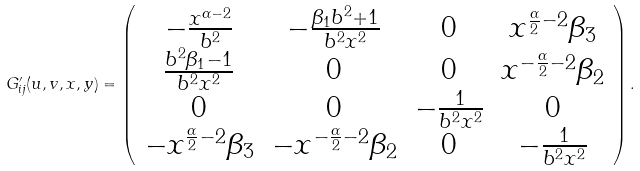Convert formula to latex. <formula><loc_0><loc_0><loc_500><loc_500>G ^ { \prime } _ { i j } ( u , v , x , y ) = \left ( \begin{array} { c c c c } - \frac { x ^ { \alpha - 2 } } { b ^ { 2 } } & - \frac { { \beta _ { 1 } } b ^ { 2 } + 1 } { b ^ { 2 } x ^ { 2 } } & 0 & x ^ { \frac { \alpha } { 2 } - 2 } { \beta _ { 3 } } \\ \frac { b ^ { 2 } { \beta _ { 1 } } - 1 } { b ^ { 2 } x ^ { 2 } } & 0 & 0 & x ^ { - \frac { \alpha } { 2 } - 2 } { \beta _ { 2 } } \\ 0 & 0 & - \frac { 1 } { b ^ { 2 } x ^ { 2 } } & 0 \\ - x ^ { \frac { \alpha } { 2 } - 2 } { \beta _ { 3 } } & - x ^ { - \frac { \alpha } { 2 } - 2 } { \beta _ { 2 } } & 0 & - \frac { 1 } { b ^ { 2 } x ^ { 2 } } \end{array} \right ) .</formula> 